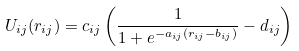<formula> <loc_0><loc_0><loc_500><loc_500>U _ { i j } ( r _ { i j } ) = c _ { i j } \left ( \frac { 1 } { 1 + e ^ { - a _ { i j } ( r _ { i j } - b _ { i j } ) } } - d _ { i j } \right )</formula> 